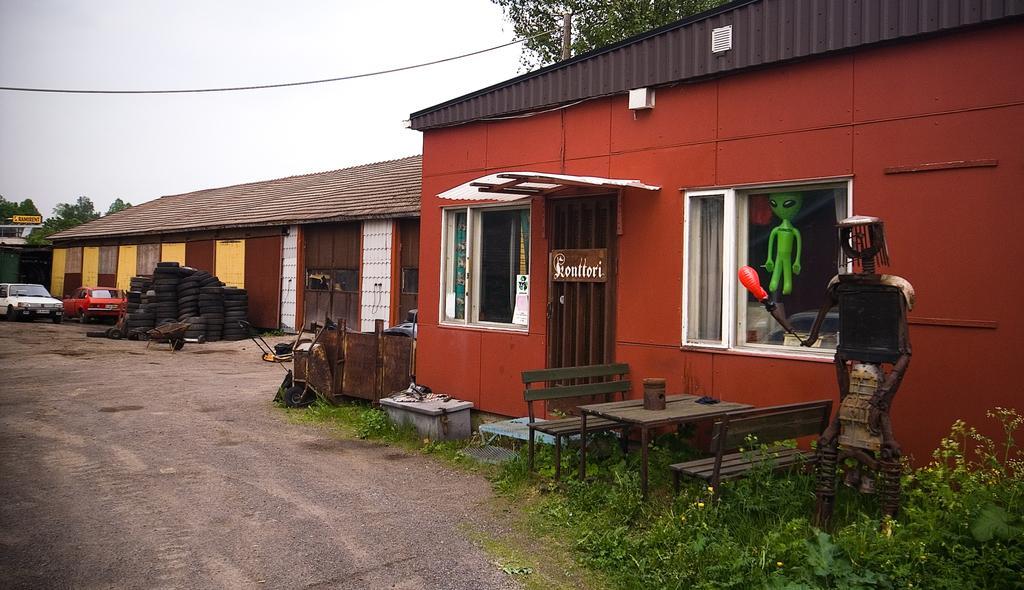Describe this image in one or two sentences. This picture describe the red color shade house with roofing tile on the top. In front we can see many black car wheel Tyre are placed. Beside we can see white and red color car is parked. On the right corner we can see a wooden table and bench placed in front of the shed house. 